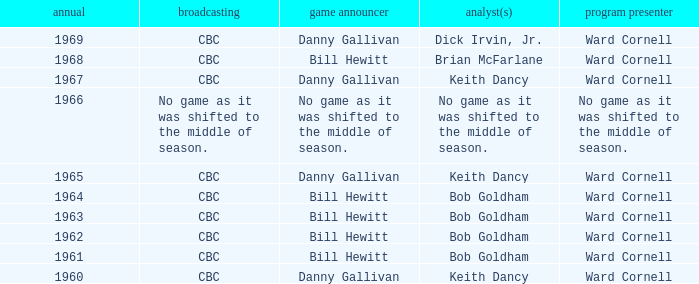Would you mind parsing the complete table? {'header': ['annual', 'broadcasting', 'game announcer', 'analyst(s)', 'program presenter'], 'rows': [['1969', 'CBC', 'Danny Gallivan', 'Dick Irvin, Jr.', 'Ward Cornell'], ['1968', 'CBC', 'Bill Hewitt', 'Brian McFarlane', 'Ward Cornell'], ['1967', 'CBC', 'Danny Gallivan', 'Keith Dancy', 'Ward Cornell'], ['1966', 'No game as it was shifted to the middle of season.', 'No game as it was shifted to the middle of season.', 'No game as it was shifted to the middle of season.', 'No game as it was shifted to the middle of season.'], ['1965', 'CBC', 'Danny Gallivan', 'Keith Dancy', 'Ward Cornell'], ['1964', 'CBC', 'Bill Hewitt', 'Bob Goldham', 'Ward Cornell'], ['1963', 'CBC', 'Bill Hewitt', 'Bob Goldham', 'Ward Cornell'], ['1962', 'CBC', 'Bill Hewitt', 'Bob Goldham', 'Ward Cornell'], ['1961', 'CBC', 'Bill Hewitt', 'Bob Goldham', 'Ward Cornell'], ['1960', 'CBC', 'Danny Gallivan', 'Keith Dancy', 'Ward Cornell']]} Who did the play-by-play with studio host Ward Cornell and color commentator Bob Goldham? Bill Hewitt, Bill Hewitt, Bill Hewitt, Bill Hewitt. 